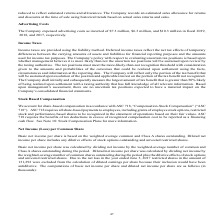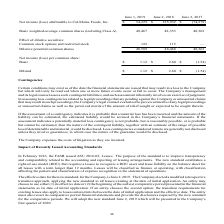Looking at Cal Maine Foods's financial data, please calculate: What is the increase in net income (loss) from 2018 to 2019? Based on the calculation: 54,229 - 125,932, the result is -71703 (in thousands). This is based on the information: "attributable to Cal-Maine Foods, Inc. $ 54,229 $ 125,932 $ (74,278) Basic weighted-average common shares (including Class A) 48,467 48,353 48,362 Effect of me (loss) attributable to Cal-Maine Foods, I..." The key data points involved are: 125,932, 54,229. Also, What is the number of common shares in the market in June 2019? According to the financial document, 48,467. The relevant text states: "eighted-average common shares (including Class A) 48,467 48,353 48,362 Effect of dilutive securities: Common stock options and restricted stock 122 115 — Di..." Also, How is the diluted net income per share calculated? net income per share was calculated by dividing net income by the weighted-average number of common shares outstanding during the period plus the dilutive effects of stock options and unvested restricted shares. The document states: "s A shares outstanding during the period. Diluted net income per share was calculated by dividing net income by the weighted-average number of common ..." Also, What is the number of common and restricted stock option in 2019? According to the financial document, 122. The relevant text states: "rities: Common stock options and restricted stock 122 115 — Dilutive potential common shares 48,589 48,468 48,362 Net income (loss) per common share: Bas..." Also, can you calculate: What is the average of the last 3 years basic net income per common share? To answer this question, I need to perform calculations using the financial data. The calculation is: (1.12 + 2.60 - 1.54) / 3, which equals 0.73 (in thousands). This is based on the information: "et income (loss) per common share: Basic $ 1.12 $ 2.60 $ (1.54) Diluted $ 1.12 $ 2.60 $ (1.54) 8,362 Net income (loss) per common share: Basic $ 1.12 $ 2.60 $ (1.54) Diluted $ 1.12 $ 2.60 $ (1.54) e (..." The key data points involved are: 1.12, 1.54, 2.60. Also, can you calculate: What is the increase / decrease in the number of dilutive potential common shares from 2018 to 2019? Based on the calculation: 48,589 - 48,468, the result is 121. This is based on the information: "122 115 — Dilutive potential common shares 48,589 48,468 48,362 Net income (loss) per common share: Basic $ 1.12 $ 2.60 $ (1.54) Diluted $ 1.12 $ 2.60 $ (1. stock 122 115 — Dilutive potential common s..." The key data points involved are: 48,468, 48,589. 